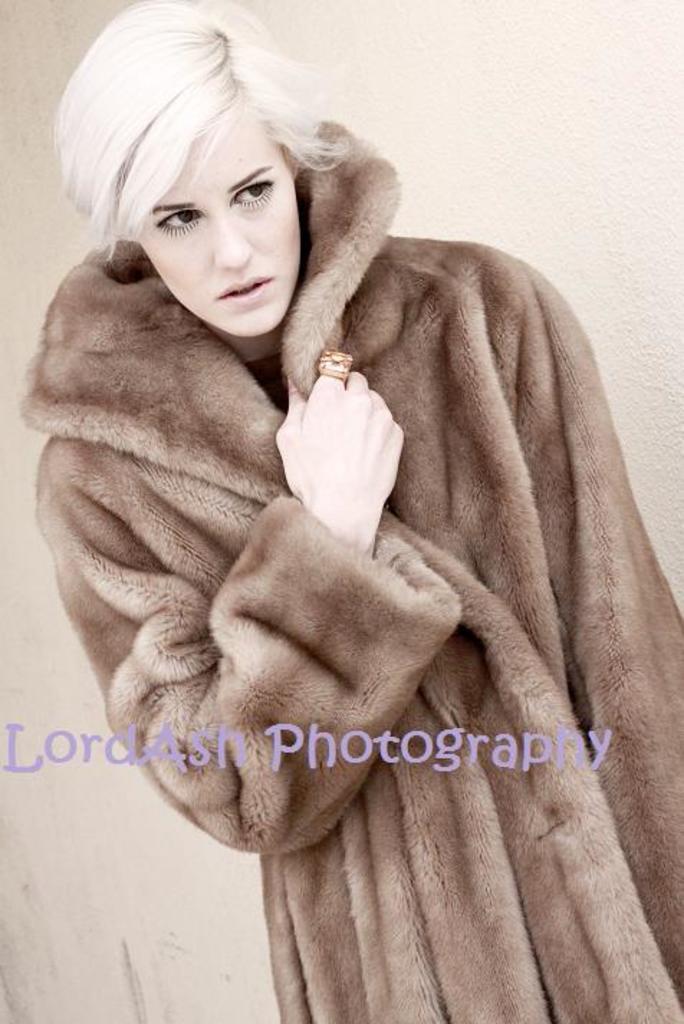Please provide a concise description of this image. In this image there is woman standing wearing a sweater, in the middle there is a text. 